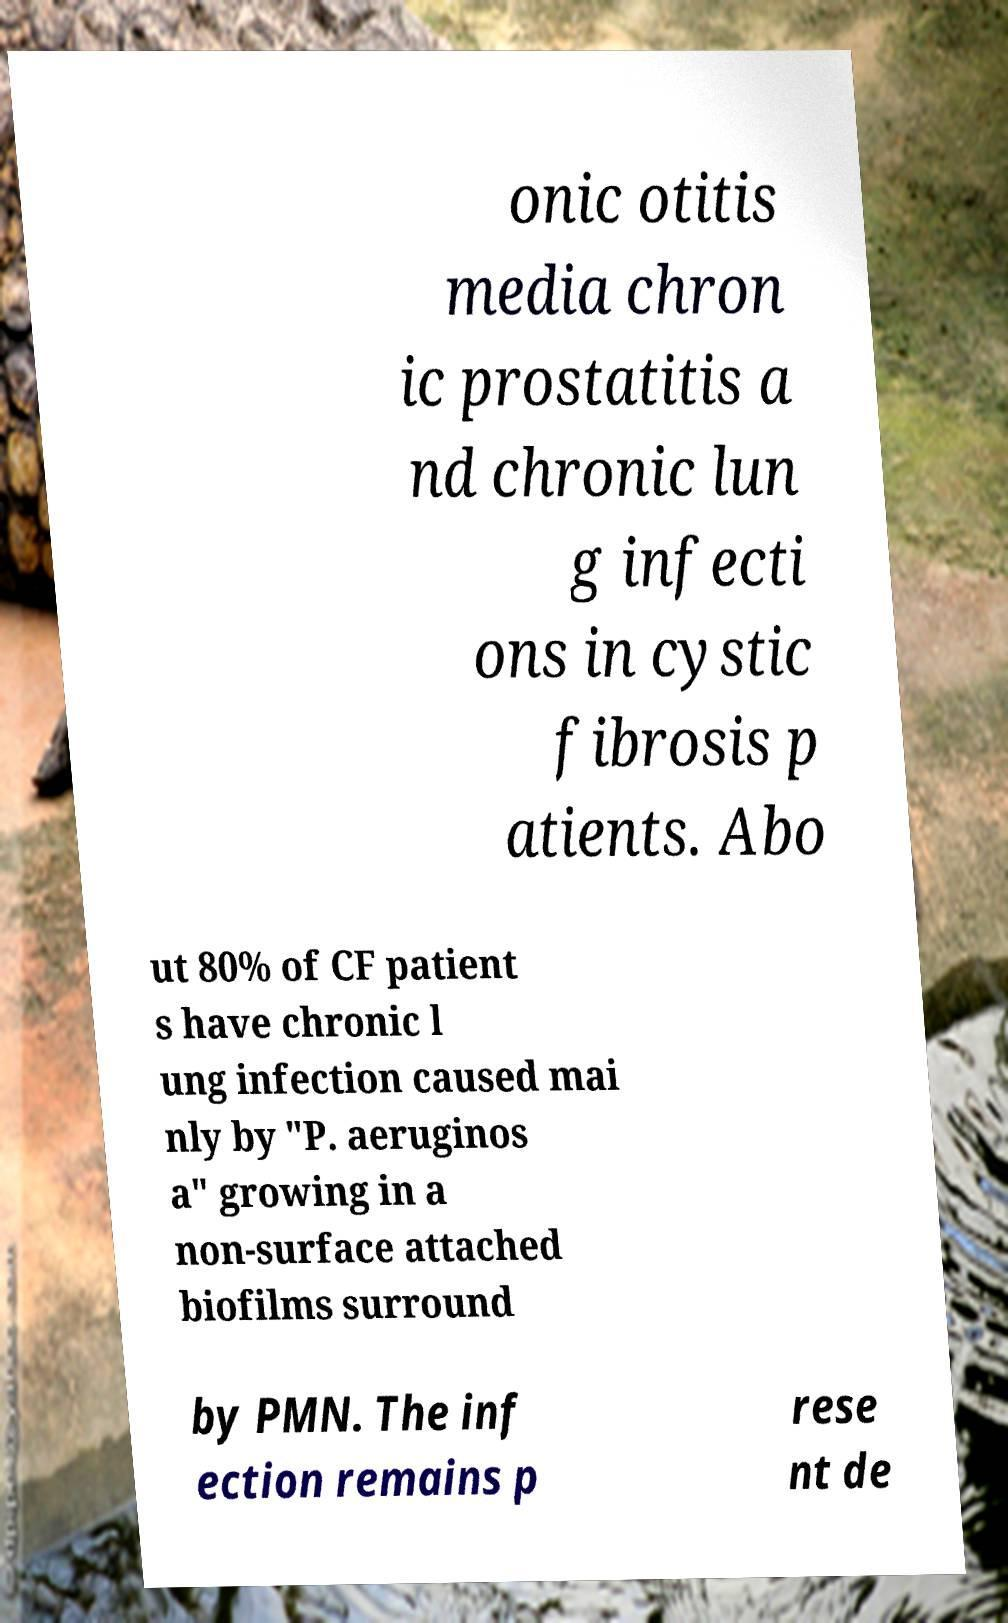Could you assist in decoding the text presented in this image and type it out clearly? onic otitis media chron ic prostatitis a nd chronic lun g infecti ons in cystic fibrosis p atients. Abo ut 80% of CF patient s have chronic l ung infection caused mai nly by "P. aeruginos a" growing in a non-surface attached biofilms surround by PMN. The inf ection remains p rese nt de 